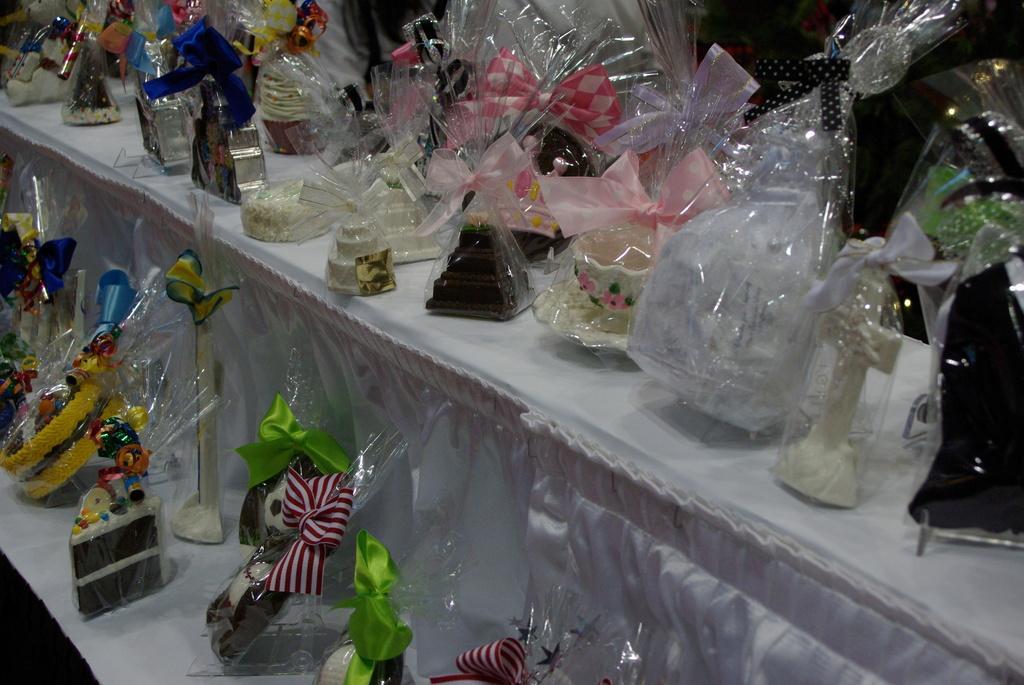How would you summarize this image in a sentence or two? In this image, we can see different types of figurines are packed and placed on the stand. 